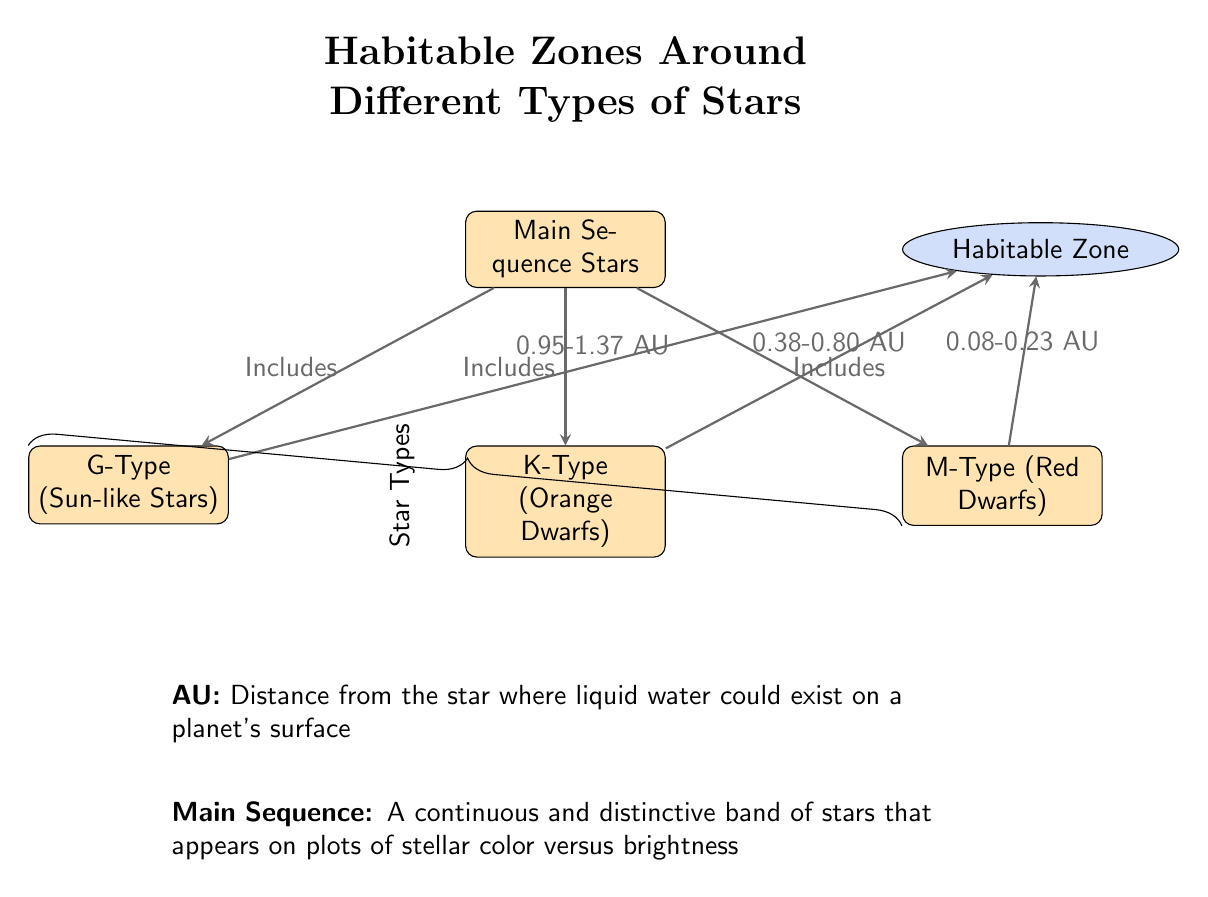What types of stars are included under Main Sequence Stars? The diagram lists three types of stars under Main Sequence Stars: G-Type (Sun-like Stars), K-Type (Orange Dwarfs), and M-Type (Red Dwarfs). Therefore, the answer can be found by identifying these star types directly connected to Main Sequence Stars in the diagram.
Answer: G-Type, K-Type, M-Type What is the habitable zone range for G-Type stars? In the diagram, the habitable zone range for G-Type stars is directly specified as being between 0.95 AU and 1.37 AU. This information is linked from the G-Type star node to the Habitable Zone concept, confirming the specifics.
Answer: 0.95-1.37 AU Which star type has the smallest habitable zone? By examining the connections between each star type and the respective habitable zone, it is evident that M-Type (Red Dwarfs) has the smallest range, indicated as 0.08 to 0.23 AU. This can be verified by checking the connections leading to the Habitable Zone from each star type.
Answer: M-Type How many types of stars are illustrated in the diagram? The diagram distinctly includes three types of stars that fall under the Main Sequence category. Each star type is represented as a separate node, and counting these gives the final answer.
Answer: 3 What relationship is indicated between Main Sequence Stars and Habitable Zone? The diagram shows that all types of stars (G-Type, K-Type, M-Type) included under Main Sequence Stars have a relationship where they all lead to the concept of the Habitable Zone. This suggests that habitable zones exist for all these star types.
Answer: Includes Which star type has a habitable zone range that overlaps with Earth's? By looking at the specified habitable zones, G-Type stars have a range of 0.95 to 1.37 AU, which overlaps with Earth's own distance from the Sun (1 AU). This characteristic indicates that G-Type stars correspond most closely to conditions similar to those of Earth.
Answer: G-Type 